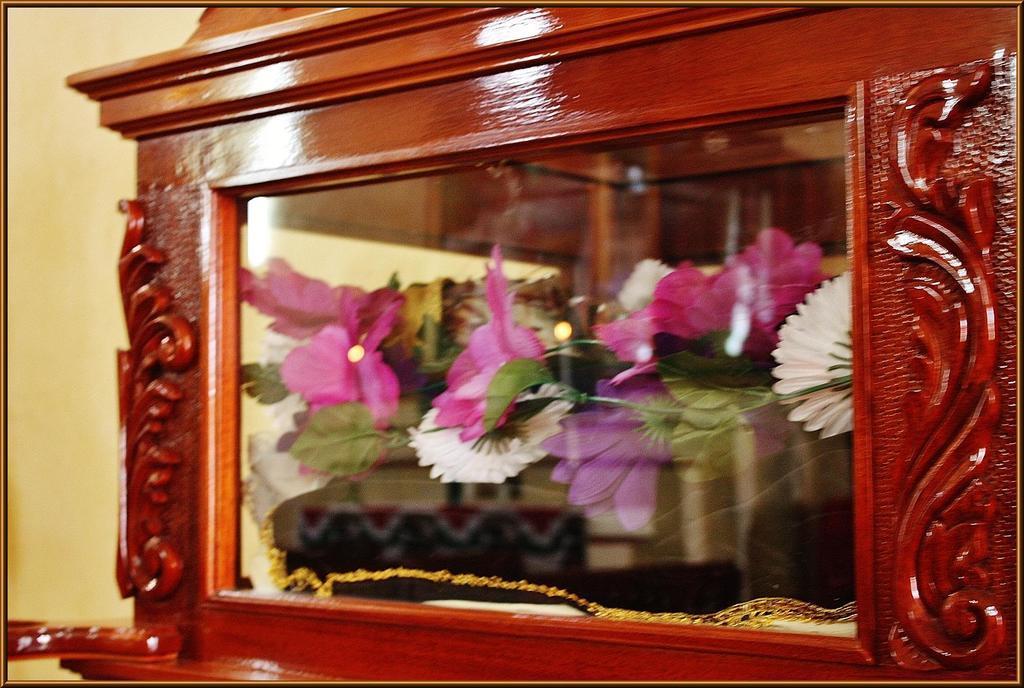Could you give a brief overview of what you see in this image? In this image we can see a cupboard. Inside the cupboard flowers are there. 